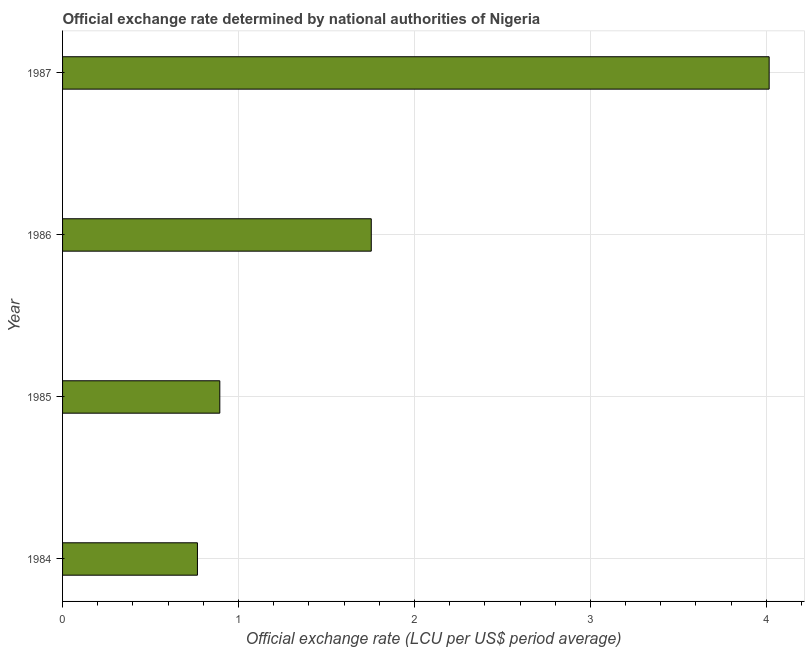Does the graph contain any zero values?
Offer a terse response. No. What is the title of the graph?
Give a very brief answer. Official exchange rate determined by national authorities of Nigeria. What is the label or title of the X-axis?
Offer a terse response. Official exchange rate (LCU per US$ period average). What is the label or title of the Y-axis?
Make the answer very short. Year. What is the official exchange rate in 1986?
Your answer should be very brief. 1.75. Across all years, what is the maximum official exchange rate?
Make the answer very short. 4.02. Across all years, what is the minimum official exchange rate?
Give a very brief answer. 0.77. In which year was the official exchange rate maximum?
Ensure brevity in your answer.  1987. What is the sum of the official exchange rate?
Your answer should be compact. 7.43. What is the difference between the official exchange rate in 1985 and 1987?
Your response must be concise. -3.12. What is the average official exchange rate per year?
Provide a succinct answer. 1.86. What is the median official exchange rate?
Provide a succinct answer. 1.32. Do a majority of the years between 1986 and 1987 (inclusive) have official exchange rate greater than 0.4 ?
Offer a terse response. Yes. What is the ratio of the official exchange rate in 1985 to that in 1987?
Your answer should be very brief. 0.22. Is the difference between the official exchange rate in 1984 and 1985 greater than the difference between any two years?
Provide a short and direct response. No. What is the difference between the highest and the second highest official exchange rate?
Give a very brief answer. 2.26. What is the difference between the highest and the lowest official exchange rate?
Your response must be concise. 3.25. How many bars are there?
Provide a short and direct response. 4. Are all the bars in the graph horizontal?
Your answer should be very brief. Yes. What is the Official exchange rate (LCU per US$ period average) in 1984?
Keep it short and to the point. 0.77. What is the Official exchange rate (LCU per US$ period average) in 1985?
Provide a short and direct response. 0.89. What is the Official exchange rate (LCU per US$ period average) in 1986?
Offer a terse response. 1.75. What is the Official exchange rate (LCU per US$ period average) of 1987?
Ensure brevity in your answer.  4.02. What is the difference between the Official exchange rate (LCU per US$ period average) in 1984 and 1985?
Offer a terse response. -0.13. What is the difference between the Official exchange rate (LCU per US$ period average) in 1984 and 1986?
Make the answer very short. -0.99. What is the difference between the Official exchange rate (LCU per US$ period average) in 1984 and 1987?
Offer a terse response. -3.25. What is the difference between the Official exchange rate (LCU per US$ period average) in 1985 and 1986?
Keep it short and to the point. -0.86. What is the difference between the Official exchange rate (LCU per US$ period average) in 1985 and 1987?
Provide a short and direct response. -3.12. What is the difference between the Official exchange rate (LCU per US$ period average) in 1986 and 1987?
Your response must be concise. -2.26. What is the ratio of the Official exchange rate (LCU per US$ period average) in 1984 to that in 1985?
Provide a succinct answer. 0.86. What is the ratio of the Official exchange rate (LCU per US$ period average) in 1984 to that in 1986?
Offer a terse response. 0.44. What is the ratio of the Official exchange rate (LCU per US$ period average) in 1984 to that in 1987?
Offer a very short reply. 0.19. What is the ratio of the Official exchange rate (LCU per US$ period average) in 1985 to that in 1986?
Provide a succinct answer. 0.51. What is the ratio of the Official exchange rate (LCU per US$ period average) in 1985 to that in 1987?
Your response must be concise. 0.22. What is the ratio of the Official exchange rate (LCU per US$ period average) in 1986 to that in 1987?
Your response must be concise. 0.44. 